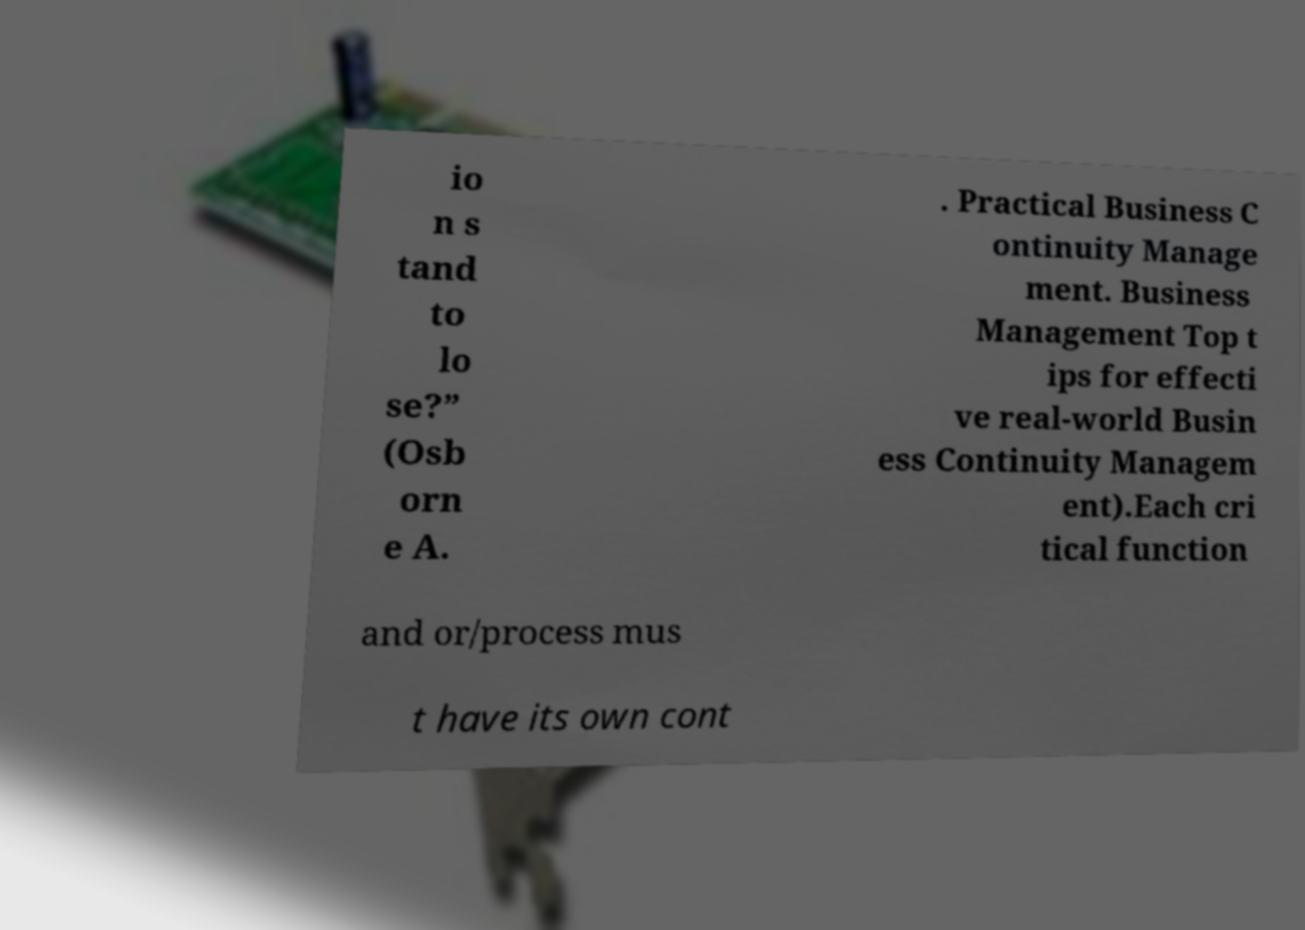Please identify and transcribe the text found in this image. io n s tand to lo se?” (Osb orn e A. . Practical Business C ontinuity Manage ment. Business Management Top t ips for effecti ve real-world Busin ess Continuity Managem ent).Each cri tical function and or/process mus t have its own cont 